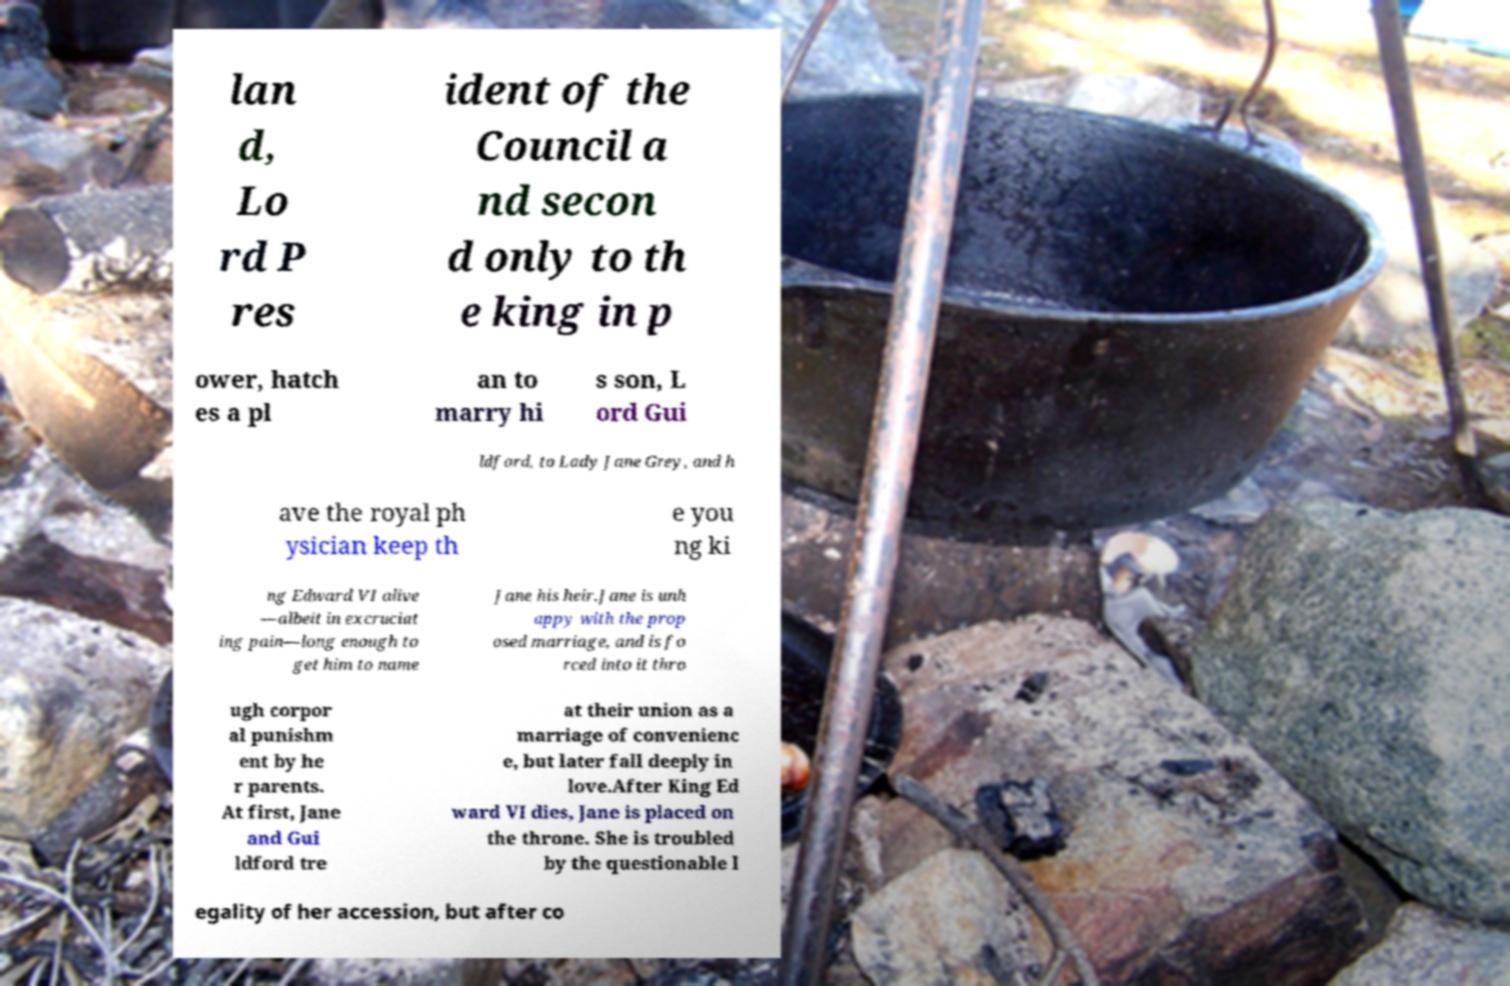Can you read and provide the text displayed in the image?This photo seems to have some interesting text. Can you extract and type it out for me? lan d, Lo rd P res ident of the Council a nd secon d only to th e king in p ower, hatch es a pl an to marry hi s son, L ord Gui ldford, to Lady Jane Grey, and h ave the royal ph ysician keep th e you ng ki ng Edward VI alive —albeit in excruciat ing pain—long enough to get him to name Jane his heir.Jane is unh appy with the prop osed marriage, and is fo rced into it thro ugh corpor al punishm ent by he r parents. At first, Jane and Gui ldford tre at their union as a marriage of convenienc e, but later fall deeply in love.After King Ed ward VI dies, Jane is placed on the throne. She is troubled by the questionable l egality of her accession, but after co 